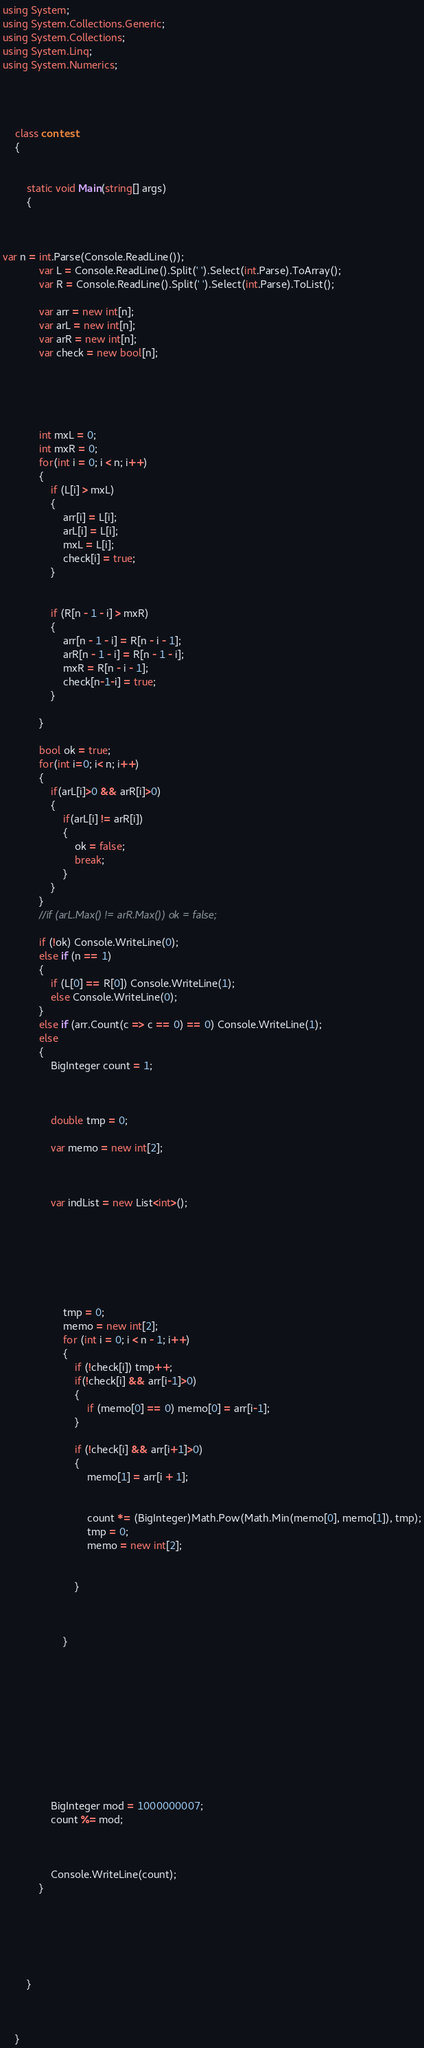<code> <loc_0><loc_0><loc_500><loc_500><_C#_>using System;
using System.Collections.Generic;
using System.Collections;
using System.Linq;
using System.Numerics;




	class contest
	{
				
		
		static void Main(string[] args)
		{

		  

var n = int.Parse(Console.ReadLine());
            var L = Console.ReadLine().Split(' ').Select(int.Parse).ToArray();            
            var R = Console.ReadLine().Split(' ').Select(int.Parse).ToList();

            var arr = new int[n];
            var arL = new int[n];
            var arR = new int[n];
            var check = new bool[n];


           


            int mxL = 0;
            int mxR = 0;
            for(int i = 0; i < n; i++)
            {
                if (L[i] > mxL)
                {
                    arr[i] = L[i];
                    arL[i] = L[i];
                    mxL = L[i];
                    check[i] = true;
                }
               

                if (R[n - 1 - i] > mxR)
                {
                    arr[n - 1 - i] = R[n - i - 1];
                    arR[n - 1 - i] = R[n - 1 - i];
                    mxR = R[n - i - 1];
                    check[n-1-i] = true;
                }
                
            }

            bool ok = true;
            for(int i=0; i< n; i++)
            {
                if(arL[i]>0 && arR[i]>0)
                {
                    if(arL[i] != arR[i])
                    {
                        ok = false;
                        break;
                    }
                }
            }
            //if (arL.Max() != arR.Max()) ok = false;

            if (!ok) Console.WriteLine(0);
            else if (n == 1)
            {
                if (L[0] == R[0]) Console.WriteLine(1);
                else Console.WriteLine(0);
            }
            else if (arr.Count(c => c == 0) == 0) Console.WriteLine(1);
            else
            {
                BigInteger count = 1;
                


                double tmp = 0;

                var memo = new int[2];



                var indList = new List<int>();


               



               
                    tmp = 0;
                    memo = new int[2];
                    for (int i = 0; i < n - 1; i++)
                    {
                        if (!check[i]) tmp++;
                        if(!check[i] && arr[i-1]>0)
                        {
                            if (memo[0] == 0) memo[0] = arr[i-1];
                        }

                        if (!check[i] && arr[i+1]>0)
                        {
                            memo[1] = arr[i + 1];
                            

                            count *= (BigInteger)Math.Pow(Math.Min(memo[0], memo[1]), tmp);
                            tmp = 0;
                            memo = new int[2];


                        }

                        
                      
                    }

                







             

                BigInteger mod = 1000000007;
                count %= mod;



                Console.WriteLine(count);
            }

            



		
        }
		
		
			
	}
</code> 